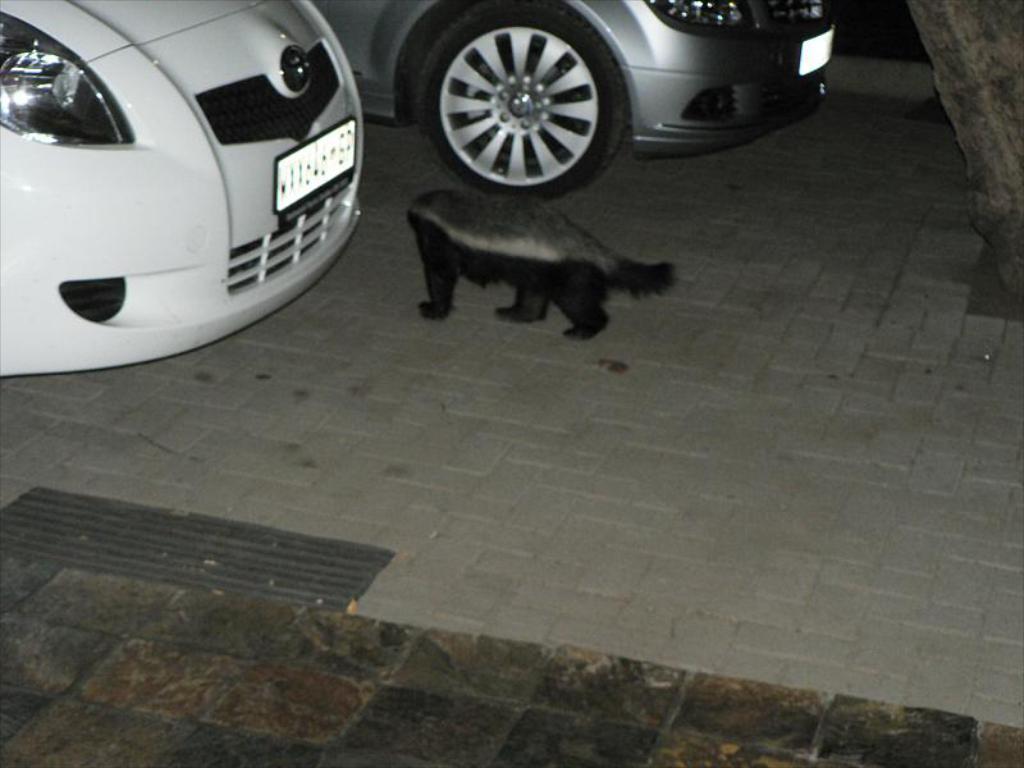Please provide a concise description of this image. This picture shows couple of cars parked and we see a dog puppy on the floor. It is black in color. 